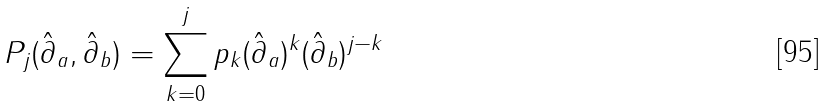Convert formula to latex. <formula><loc_0><loc_0><loc_500><loc_500>P _ { j } ( \hat { \partial } _ { a } , \hat { \partial } _ { b } ) = \sum _ { k = 0 } ^ { j } p _ { k } ( \hat { \partial } _ { a } ) ^ { k } ( \hat { \partial } _ { b } ) ^ { j - k }</formula> 